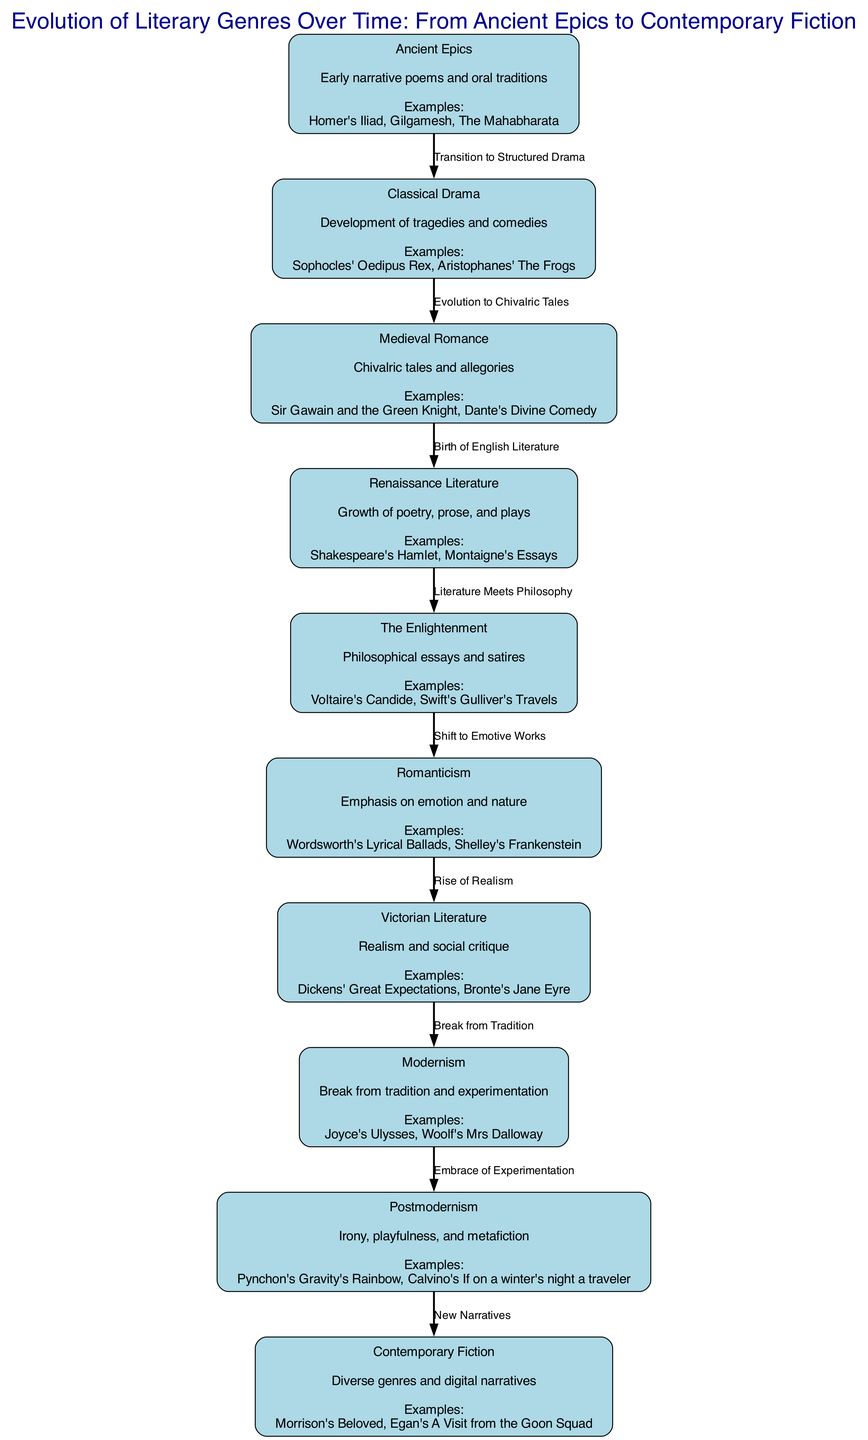What is the first genre listed in the diagram? The first genre mentioned in the diagram is "Ancient Epics." It is the initial node at the top of the diagram, indicating the starting point of the evolution of literary genres.
Answer: Ancient Epics How many genres are represented in the diagram? By counting the nodes listed in the diagram, there are a total of ten genres represented. This includes all the nodes mentioned from "Ancient Epics" to "Contemporary Fiction."
Answer: 10 What is the relationship between "Romanticism" and "Victorian Literature"? The diagram indicates a direct transition from "Romanticism" to "Victorian Literature" with the label "Rise of Realism," illustrating how Romanticism paved the way for the more realistic portrayals of life in Victorian literature.
Answer: Rise of Realism Which literary genre is characterized by philosophical essays and satires? According to the diagram, "The Enlightenment" is specifically noted for its focus on philosophical essays and satires, highlighting a significant aspect of this literary period.
Answer: The Enlightenment What is an example of a work listed under "Postmodernism"? The diagram provides two examples for "Postmodernism," one of which is "Pynchon's Gravity's Rainbow." Pynchon's work exemplifies the key characteristics associated with this literary period.
Answer: Pynchon's Gravity's Rainbow Explain the transition from "Renaissance Literature" to "Enlightenment." The diagram shows that "Renaissance Literature" transitions to "Enlightenment" with the label "Literature Meets Philosophy." This indicates that during the Enlightenment, there was an increased engagement with philosophy, building upon the foundation laid in the Renaissance.
Answer: Literature Meets Philosophy How does "Modernism" relate to "Postmodernism" in the diagram? The diagram captures the relationship between "Modernism" and "Postmodernism" through the label "Embrace of Experimentation," suggesting that postmodern literature found its roots in the experimental nature of modernist works.
Answer: Embrace of Experimentation What genre follows "Medieval Romance" in the timeline? The diagram shows that "Renaissance Literature" directly follows "Medieval Romance," indicating the evolution of literary forms leading into this significant cultural period.
Answer: Renaissance Literature Which genre showcases an emphasis on emotion and nature? "Romanticism" is identified in the diagram as the genre that places a significant emphasis on emotion and nature, marking a departure from the previous literary styles.
Answer: Romanticism 